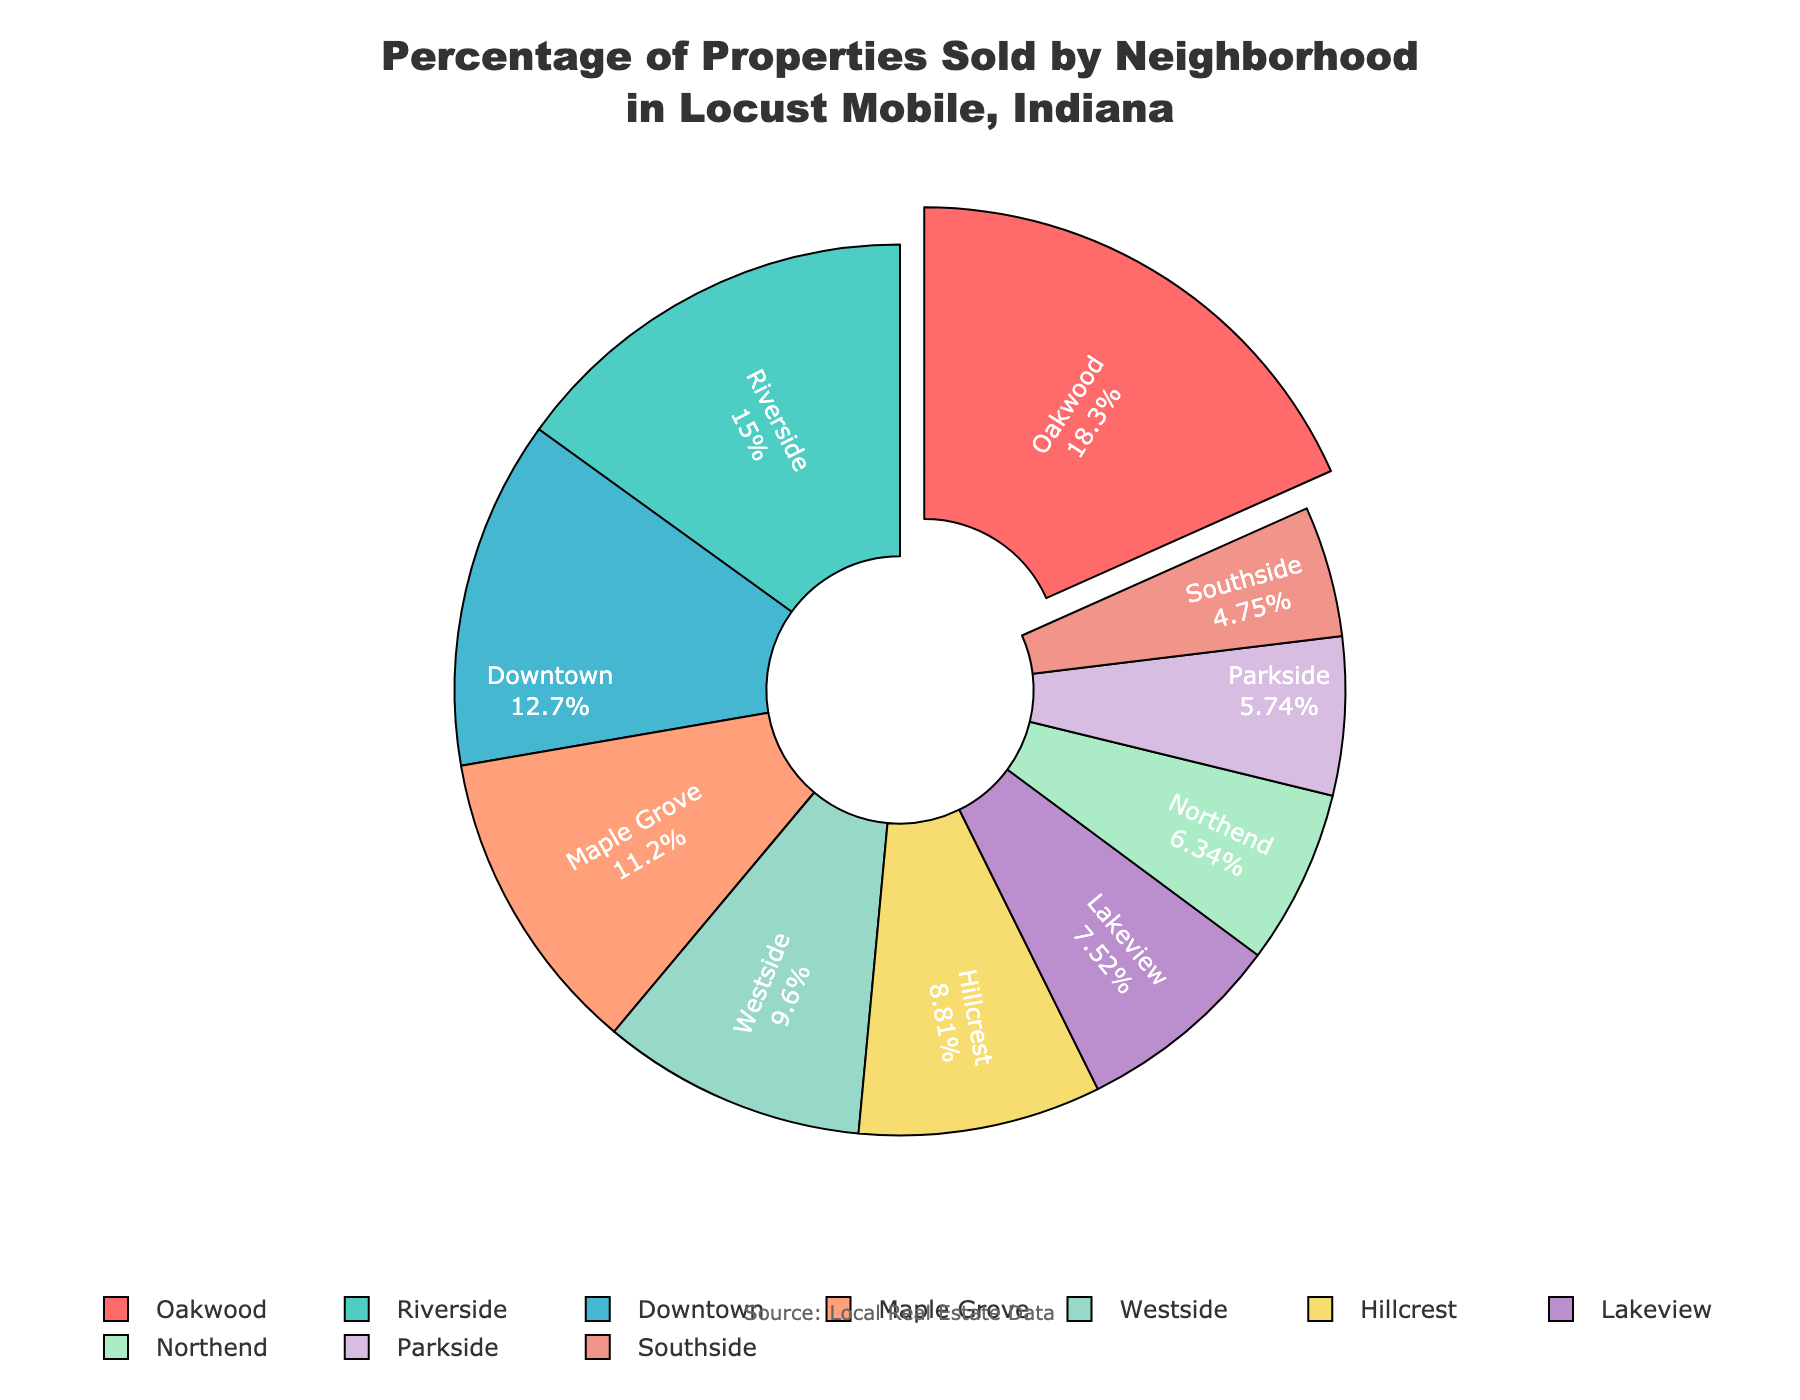Which neighborhood has the highest percentage of properties sold? Observe the segment that is slightly pulled out from the pie chart. This visual cue highlights the neighborhood with the highest percentage.
Answer: Oakwood Which neighborhood has the lowest percentage of properties sold? Find the segment with the smallest size in the pie chart.
Answer: Southside What is the combined percentage of properties sold in Oakwood and Riverside? Add the percentages of Oakwood (18.5%) and Riverside (15.2%) together: 18.5 + 15.2 = 33.7%.
Answer: 33.7% How does the percentage of properties sold in Downtown compare to Westside? Compare the sizes and percentages labeled for Downtown (12.8%) and Westside (9.7%). Downtown has a higher percentage than Westside.
Answer: Downtown is higher Which neighborhoods have a percentage of properties sold greater than 10%? Look at the labels on the pie chart and identify those with percentages greater than 10%. They are Oakwood (18.5%), Riverside (15.2%), Downtown (12.8%), and Maple Grove (11.3%).
Answer: Oakwood, Riverside, Downtown, Maple Grove What is the total percentage of properties sold in neighborhoods with less than 10% each? Add the percentages of neighborhoods below 10%: Westside (9.7%), Hillcrest (8.9%), Lakeview (7.6%), Northend (6.4%), Parkside (5.8%), and Southside (4.8%). 9.7 + 8.9 + 7.6 + 6.4 + 5.8 + 4.8 = 43.2%.
Answer: 43.2% Which neighborhood's segment is represented by a shade of blue, and what is its percentage? Identify the segment colored in blue and read its percentage label from the pie chart.
Answer: Riverside, 15.2% What is the difference in the percentage of properties sold between Riversides and Lakeview? Subtract the percentage of Lakeview (7.6%) from that of Riverside (15.2%): 15.2 - 7.6 = 7.6%.
Answer: 7.6% Which three neighborhoods have the approximately smallest share of properties sold, and what are their combined percentages? Identify the three segments with the smallest sizes and add their percentages: Southside (4.8%), Parkside (5.8%), and Northend (6.4%). 4.8 + 5.8 + 6.4 = 17.0%.
Answer: Southside, Parkside, Northend, 17.0% If Lakeview's percentage increased by 2%, how would its new percentage compare to Hillcrest’s current percentage? Calculate Lakeview's new percentage by adding 2% to its current percentage (7.6 + 2 = 9.6%). Then compare it to Hillcrest's percentage (8.9%). Lakeview’s new percentage (9.6%) would be higher than Hillcrest’s current (8.9%).
Answer: Lakeview would be higher 